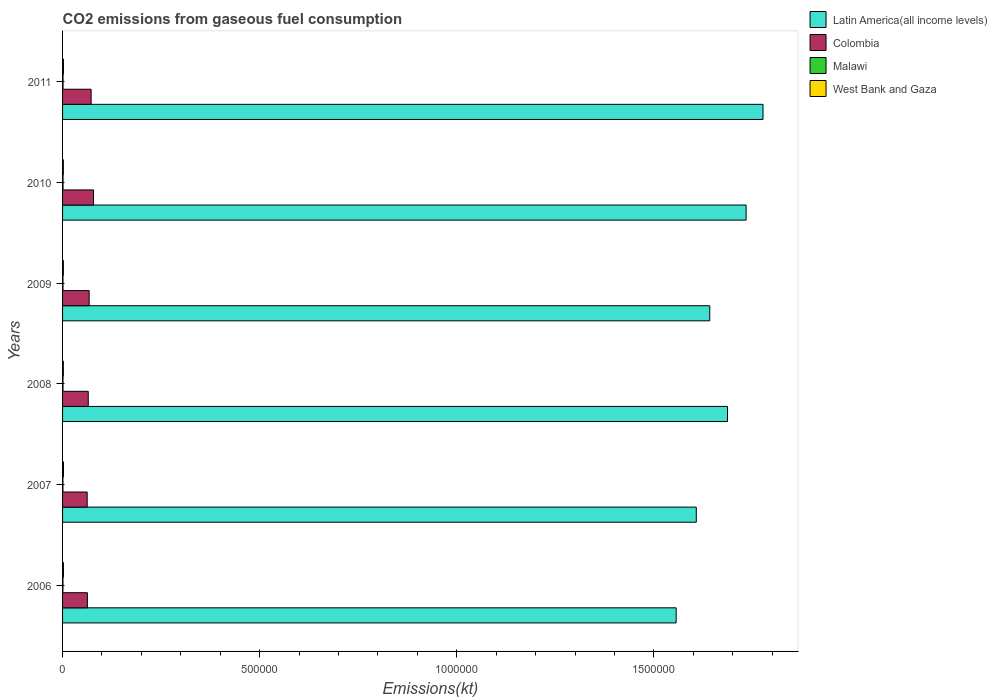Are the number of bars on each tick of the Y-axis equal?
Offer a terse response. Yes. How many bars are there on the 6th tick from the top?
Your response must be concise. 4. In how many cases, is the number of bars for a given year not equal to the number of legend labels?
Ensure brevity in your answer.  0. What is the amount of CO2 emitted in Malawi in 2011?
Provide a short and direct response. 1206.44. Across all years, what is the maximum amount of CO2 emitted in West Bank and Gaza?
Give a very brief answer. 2324.88. Across all years, what is the minimum amount of CO2 emitted in Malawi?
Ensure brevity in your answer.  953.42. What is the total amount of CO2 emitted in West Bank and Gaza in the graph?
Offer a very short reply. 1.30e+04. What is the difference between the amount of CO2 emitted in West Bank and Gaza in 2006 and that in 2007?
Your answer should be compact. -58.67. What is the difference between the amount of CO2 emitted in Malawi in 2009 and the amount of CO2 emitted in Latin America(all income levels) in 2008?
Offer a very short reply. -1.69e+06. What is the average amount of CO2 emitted in Colombia per year?
Your response must be concise. 6.82e+04. In the year 2008, what is the difference between the amount of CO2 emitted in Colombia and amount of CO2 emitted in Malawi?
Your answer should be very brief. 6.40e+04. In how many years, is the amount of CO2 emitted in Latin America(all income levels) greater than 700000 kt?
Ensure brevity in your answer.  6. What is the ratio of the amount of CO2 emitted in Colombia in 2008 to that in 2010?
Make the answer very short. 0.83. Is the amount of CO2 emitted in West Bank and Gaza in 2007 less than that in 2009?
Offer a terse response. No. Is the difference between the amount of CO2 emitted in Colombia in 2006 and 2009 greater than the difference between the amount of CO2 emitted in Malawi in 2006 and 2009?
Your answer should be very brief. No. What is the difference between the highest and the second highest amount of CO2 emitted in Malawi?
Your response must be concise. 7.33. What is the difference between the highest and the lowest amount of CO2 emitted in West Bank and Gaza?
Offer a terse response. 289.69. Is the sum of the amount of CO2 emitted in Malawi in 2007 and 2011 greater than the maximum amount of CO2 emitted in Latin America(all income levels) across all years?
Provide a succinct answer. No. Is it the case that in every year, the sum of the amount of CO2 emitted in Malawi and amount of CO2 emitted in Colombia is greater than the sum of amount of CO2 emitted in Latin America(all income levels) and amount of CO2 emitted in West Bank and Gaza?
Keep it short and to the point. Yes. What does the 4th bar from the top in 2008 represents?
Offer a very short reply. Latin America(all income levels). What does the 1st bar from the bottom in 2010 represents?
Keep it short and to the point. Latin America(all income levels). Are all the bars in the graph horizontal?
Provide a succinct answer. Yes. Are the values on the major ticks of X-axis written in scientific E-notation?
Your answer should be very brief. No. Does the graph contain grids?
Give a very brief answer. No. What is the title of the graph?
Offer a very short reply. CO2 emissions from gaseous fuel consumption. Does "Somalia" appear as one of the legend labels in the graph?
Ensure brevity in your answer.  No. What is the label or title of the X-axis?
Provide a succinct answer. Emissions(kt). What is the Emissions(kt) of Latin America(all income levels) in 2006?
Your response must be concise. 1.56e+06. What is the Emissions(kt) of Colombia in 2006?
Keep it short and to the point. 6.29e+04. What is the Emissions(kt) of Malawi in 2006?
Make the answer very short. 953.42. What is the Emissions(kt) of West Bank and Gaza in 2006?
Keep it short and to the point. 2266.21. What is the Emissions(kt) in Latin America(all income levels) in 2007?
Provide a succinct answer. 1.61e+06. What is the Emissions(kt) of Colombia in 2007?
Provide a short and direct response. 6.24e+04. What is the Emissions(kt) of Malawi in 2007?
Offer a terse response. 953.42. What is the Emissions(kt) of West Bank and Gaza in 2007?
Offer a very short reply. 2324.88. What is the Emissions(kt) in Latin America(all income levels) in 2008?
Ensure brevity in your answer.  1.69e+06. What is the Emissions(kt) of Colombia in 2008?
Offer a terse response. 6.52e+04. What is the Emissions(kt) of Malawi in 2008?
Provide a succinct answer. 1147.77. What is the Emissions(kt) in West Bank and Gaza in 2008?
Offer a very short reply. 2053.52. What is the Emissions(kt) of Latin America(all income levels) in 2009?
Offer a very short reply. 1.64e+06. What is the Emissions(kt) of Colombia in 2009?
Give a very brief answer. 6.74e+04. What is the Emissions(kt) of Malawi in 2009?
Offer a terse response. 1056.1. What is the Emissions(kt) in West Bank and Gaza in 2009?
Offer a terse response. 2090.19. What is the Emissions(kt) of Latin America(all income levels) in 2010?
Offer a terse response. 1.73e+06. What is the Emissions(kt) of Colombia in 2010?
Offer a very short reply. 7.86e+04. What is the Emissions(kt) of Malawi in 2010?
Ensure brevity in your answer.  1213.78. What is the Emissions(kt) in West Bank and Gaza in 2010?
Provide a succinct answer. 2035.18. What is the Emissions(kt) of Latin America(all income levels) in 2011?
Provide a short and direct response. 1.78e+06. What is the Emissions(kt) in Colombia in 2011?
Provide a short and direct response. 7.24e+04. What is the Emissions(kt) of Malawi in 2011?
Provide a short and direct response. 1206.44. What is the Emissions(kt) of West Bank and Gaza in 2011?
Your answer should be compact. 2247.87. Across all years, what is the maximum Emissions(kt) in Latin America(all income levels)?
Make the answer very short. 1.78e+06. Across all years, what is the maximum Emissions(kt) of Colombia?
Your response must be concise. 7.86e+04. Across all years, what is the maximum Emissions(kt) of Malawi?
Keep it short and to the point. 1213.78. Across all years, what is the maximum Emissions(kt) in West Bank and Gaza?
Your answer should be compact. 2324.88. Across all years, what is the minimum Emissions(kt) of Latin America(all income levels)?
Your answer should be compact. 1.56e+06. Across all years, what is the minimum Emissions(kt) of Colombia?
Your answer should be compact. 6.24e+04. Across all years, what is the minimum Emissions(kt) of Malawi?
Make the answer very short. 953.42. Across all years, what is the minimum Emissions(kt) of West Bank and Gaza?
Keep it short and to the point. 2035.18. What is the total Emissions(kt) in Latin America(all income levels) in the graph?
Provide a succinct answer. 1.00e+07. What is the total Emissions(kt) in Colombia in the graph?
Your answer should be very brief. 4.09e+05. What is the total Emissions(kt) in Malawi in the graph?
Your response must be concise. 6530.93. What is the total Emissions(kt) in West Bank and Gaza in the graph?
Ensure brevity in your answer.  1.30e+04. What is the difference between the Emissions(kt) of Latin America(all income levels) in 2006 and that in 2007?
Your answer should be compact. -5.11e+04. What is the difference between the Emissions(kt) in Colombia in 2006 and that in 2007?
Ensure brevity in your answer.  509.71. What is the difference between the Emissions(kt) of West Bank and Gaza in 2006 and that in 2007?
Ensure brevity in your answer.  -58.67. What is the difference between the Emissions(kt) of Latin America(all income levels) in 2006 and that in 2008?
Your answer should be very brief. -1.30e+05. What is the difference between the Emissions(kt) in Colombia in 2006 and that in 2008?
Offer a very short reply. -2218.53. What is the difference between the Emissions(kt) in Malawi in 2006 and that in 2008?
Your answer should be very brief. -194.35. What is the difference between the Emissions(kt) of West Bank and Gaza in 2006 and that in 2008?
Your answer should be compact. 212.69. What is the difference between the Emissions(kt) in Latin America(all income levels) in 2006 and that in 2009?
Provide a succinct answer. -8.52e+04. What is the difference between the Emissions(kt) of Colombia in 2006 and that in 2009?
Keep it short and to the point. -4492.07. What is the difference between the Emissions(kt) in Malawi in 2006 and that in 2009?
Make the answer very short. -102.68. What is the difference between the Emissions(kt) of West Bank and Gaza in 2006 and that in 2009?
Provide a short and direct response. 176.02. What is the difference between the Emissions(kt) of Latin America(all income levels) in 2006 and that in 2010?
Keep it short and to the point. -1.77e+05. What is the difference between the Emissions(kt) of Colombia in 2006 and that in 2010?
Offer a very short reply. -1.56e+04. What is the difference between the Emissions(kt) of Malawi in 2006 and that in 2010?
Your answer should be very brief. -260.36. What is the difference between the Emissions(kt) of West Bank and Gaza in 2006 and that in 2010?
Keep it short and to the point. 231.02. What is the difference between the Emissions(kt) in Latin America(all income levels) in 2006 and that in 2011?
Give a very brief answer. -2.20e+05. What is the difference between the Emissions(kt) of Colombia in 2006 and that in 2011?
Keep it short and to the point. -9482.86. What is the difference between the Emissions(kt) in Malawi in 2006 and that in 2011?
Offer a very short reply. -253.02. What is the difference between the Emissions(kt) in West Bank and Gaza in 2006 and that in 2011?
Your answer should be very brief. 18.34. What is the difference between the Emissions(kt) in Latin America(all income levels) in 2007 and that in 2008?
Make the answer very short. -7.91e+04. What is the difference between the Emissions(kt) in Colombia in 2007 and that in 2008?
Provide a short and direct response. -2728.25. What is the difference between the Emissions(kt) in Malawi in 2007 and that in 2008?
Provide a short and direct response. -194.35. What is the difference between the Emissions(kt) of West Bank and Gaza in 2007 and that in 2008?
Keep it short and to the point. 271.36. What is the difference between the Emissions(kt) in Latin America(all income levels) in 2007 and that in 2009?
Your response must be concise. -3.41e+04. What is the difference between the Emissions(kt) in Colombia in 2007 and that in 2009?
Offer a terse response. -5001.79. What is the difference between the Emissions(kt) of Malawi in 2007 and that in 2009?
Ensure brevity in your answer.  -102.68. What is the difference between the Emissions(kt) in West Bank and Gaza in 2007 and that in 2009?
Your response must be concise. 234.69. What is the difference between the Emissions(kt) in Latin America(all income levels) in 2007 and that in 2010?
Your answer should be compact. -1.26e+05. What is the difference between the Emissions(kt) in Colombia in 2007 and that in 2010?
Make the answer very short. -1.62e+04. What is the difference between the Emissions(kt) of Malawi in 2007 and that in 2010?
Provide a succinct answer. -260.36. What is the difference between the Emissions(kt) of West Bank and Gaza in 2007 and that in 2010?
Offer a very short reply. 289.69. What is the difference between the Emissions(kt) in Latin America(all income levels) in 2007 and that in 2011?
Your answer should be very brief. -1.69e+05. What is the difference between the Emissions(kt) in Colombia in 2007 and that in 2011?
Your answer should be very brief. -9992.58. What is the difference between the Emissions(kt) in Malawi in 2007 and that in 2011?
Ensure brevity in your answer.  -253.02. What is the difference between the Emissions(kt) in West Bank and Gaza in 2007 and that in 2011?
Provide a short and direct response. 77.01. What is the difference between the Emissions(kt) of Latin America(all income levels) in 2008 and that in 2009?
Keep it short and to the point. 4.50e+04. What is the difference between the Emissions(kt) in Colombia in 2008 and that in 2009?
Offer a very short reply. -2273.54. What is the difference between the Emissions(kt) in Malawi in 2008 and that in 2009?
Offer a very short reply. 91.67. What is the difference between the Emissions(kt) in West Bank and Gaza in 2008 and that in 2009?
Your answer should be very brief. -36.67. What is the difference between the Emissions(kt) of Latin America(all income levels) in 2008 and that in 2010?
Offer a terse response. -4.72e+04. What is the difference between the Emissions(kt) in Colombia in 2008 and that in 2010?
Provide a succinct answer. -1.34e+04. What is the difference between the Emissions(kt) of Malawi in 2008 and that in 2010?
Provide a short and direct response. -66.01. What is the difference between the Emissions(kt) in West Bank and Gaza in 2008 and that in 2010?
Your answer should be compact. 18.34. What is the difference between the Emissions(kt) in Latin America(all income levels) in 2008 and that in 2011?
Offer a terse response. -9.01e+04. What is the difference between the Emissions(kt) of Colombia in 2008 and that in 2011?
Provide a short and direct response. -7264.33. What is the difference between the Emissions(kt) in Malawi in 2008 and that in 2011?
Ensure brevity in your answer.  -58.67. What is the difference between the Emissions(kt) in West Bank and Gaza in 2008 and that in 2011?
Give a very brief answer. -194.35. What is the difference between the Emissions(kt) in Latin America(all income levels) in 2009 and that in 2010?
Keep it short and to the point. -9.22e+04. What is the difference between the Emissions(kt) of Colombia in 2009 and that in 2010?
Give a very brief answer. -1.12e+04. What is the difference between the Emissions(kt) in Malawi in 2009 and that in 2010?
Ensure brevity in your answer.  -157.68. What is the difference between the Emissions(kt) in West Bank and Gaza in 2009 and that in 2010?
Provide a succinct answer. 55.01. What is the difference between the Emissions(kt) in Latin America(all income levels) in 2009 and that in 2011?
Give a very brief answer. -1.35e+05. What is the difference between the Emissions(kt) of Colombia in 2009 and that in 2011?
Make the answer very short. -4990.79. What is the difference between the Emissions(kt) in Malawi in 2009 and that in 2011?
Your answer should be compact. -150.35. What is the difference between the Emissions(kt) of West Bank and Gaza in 2009 and that in 2011?
Give a very brief answer. -157.68. What is the difference between the Emissions(kt) of Latin America(all income levels) in 2010 and that in 2011?
Offer a terse response. -4.29e+04. What is the difference between the Emissions(kt) in Colombia in 2010 and that in 2011?
Keep it short and to the point. 6160.56. What is the difference between the Emissions(kt) of Malawi in 2010 and that in 2011?
Your response must be concise. 7.33. What is the difference between the Emissions(kt) in West Bank and Gaza in 2010 and that in 2011?
Your answer should be very brief. -212.69. What is the difference between the Emissions(kt) of Latin America(all income levels) in 2006 and the Emissions(kt) of Colombia in 2007?
Ensure brevity in your answer.  1.49e+06. What is the difference between the Emissions(kt) in Latin America(all income levels) in 2006 and the Emissions(kt) in Malawi in 2007?
Your response must be concise. 1.56e+06. What is the difference between the Emissions(kt) of Latin America(all income levels) in 2006 and the Emissions(kt) of West Bank and Gaza in 2007?
Make the answer very short. 1.55e+06. What is the difference between the Emissions(kt) in Colombia in 2006 and the Emissions(kt) in Malawi in 2007?
Keep it short and to the point. 6.20e+04. What is the difference between the Emissions(kt) in Colombia in 2006 and the Emissions(kt) in West Bank and Gaza in 2007?
Provide a succinct answer. 6.06e+04. What is the difference between the Emissions(kt) in Malawi in 2006 and the Emissions(kt) in West Bank and Gaza in 2007?
Offer a terse response. -1371.46. What is the difference between the Emissions(kt) in Latin America(all income levels) in 2006 and the Emissions(kt) in Colombia in 2008?
Offer a very short reply. 1.49e+06. What is the difference between the Emissions(kt) in Latin America(all income levels) in 2006 and the Emissions(kt) in Malawi in 2008?
Your response must be concise. 1.56e+06. What is the difference between the Emissions(kt) in Latin America(all income levels) in 2006 and the Emissions(kt) in West Bank and Gaza in 2008?
Your answer should be compact. 1.55e+06. What is the difference between the Emissions(kt) in Colombia in 2006 and the Emissions(kt) in Malawi in 2008?
Provide a succinct answer. 6.18e+04. What is the difference between the Emissions(kt) of Colombia in 2006 and the Emissions(kt) of West Bank and Gaza in 2008?
Provide a succinct answer. 6.09e+04. What is the difference between the Emissions(kt) of Malawi in 2006 and the Emissions(kt) of West Bank and Gaza in 2008?
Provide a short and direct response. -1100.1. What is the difference between the Emissions(kt) of Latin America(all income levels) in 2006 and the Emissions(kt) of Colombia in 2009?
Make the answer very short. 1.49e+06. What is the difference between the Emissions(kt) in Latin America(all income levels) in 2006 and the Emissions(kt) in Malawi in 2009?
Your answer should be very brief. 1.56e+06. What is the difference between the Emissions(kt) in Latin America(all income levels) in 2006 and the Emissions(kt) in West Bank and Gaza in 2009?
Give a very brief answer. 1.55e+06. What is the difference between the Emissions(kt) in Colombia in 2006 and the Emissions(kt) in Malawi in 2009?
Your answer should be compact. 6.19e+04. What is the difference between the Emissions(kt) in Colombia in 2006 and the Emissions(kt) in West Bank and Gaza in 2009?
Provide a short and direct response. 6.09e+04. What is the difference between the Emissions(kt) of Malawi in 2006 and the Emissions(kt) of West Bank and Gaza in 2009?
Provide a succinct answer. -1136.77. What is the difference between the Emissions(kt) of Latin America(all income levels) in 2006 and the Emissions(kt) of Colombia in 2010?
Ensure brevity in your answer.  1.48e+06. What is the difference between the Emissions(kt) in Latin America(all income levels) in 2006 and the Emissions(kt) in Malawi in 2010?
Keep it short and to the point. 1.56e+06. What is the difference between the Emissions(kt) in Latin America(all income levels) in 2006 and the Emissions(kt) in West Bank and Gaza in 2010?
Keep it short and to the point. 1.55e+06. What is the difference between the Emissions(kt) in Colombia in 2006 and the Emissions(kt) in Malawi in 2010?
Your answer should be very brief. 6.17e+04. What is the difference between the Emissions(kt) in Colombia in 2006 and the Emissions(kt) in West Bank and Gaza in 2010?
Provide a short and direct response. 6.09e+04. What is the difference between the Emissions(kt) of Malawi in 2006 and the Emissions(kt) of West Bank and Gaza in 2010?
Your answer should be compact. -1081.77. What is the difference between the Emissions(kt) in Latin America(all income levels) in 2006 and the Emissions(kt) in Colombia in 2011?
Make the answer very short. 1.48e+06. What is the difference between the Emissions(kt) in Latin America(all income levels) in 2006 and the Emissions(kt) in Malawi in 2011?
Your answer should be very brief. 1.56e+06. What is the difference between the Emissions(kt) in Latin America(all income levels) in 2006 and the Emissions(kt) in West Bank and Gaza in 2011?
Give a very brief answer. 1.55e+06. What is the difference between the Emissions(kt) in Colombia in 2006 and the Emissions(kt) in Malawi in 2011?
Make the answer very short. 6.17e+04. What is the difference between the Emissions(kt) of Colombia in 2006 and the Emissions(kt) of West Bank and Gaza in 2011?
Offer a very short reply. 6.07e+04. What is the difference between the Emissions(kt) in Malawi in 2006 and the Emissions(kt) in West Bank and Gaza in 2011?
Provide a succinct answer. -1294.45. What is the difference between the Emissions(kt) of Latin America(all income levels) in 2007 and the Emissions(kt) of Colombia in 2008?
Your response must be concise. 1.54e+06. What is the difference between the Emissions(kt) in Latin America(all income levels) in 2007 and the Emissions(kt) in Malawi in 2008?
Offer a very short reply. 1.61e+06. What is the difference between the Emissions(kt) of Latin America(all income levels) in 2007 and the Emissions(kt) of West Bank and Gaza in 2008?
Make the answer very short. 1.61e+06. What is the difference between the Emissions(kt) in Colombia in 2007 and the Emissions(kt) in Malawi in 2008?
Provide a short and direct response. 6.13e+04. What is the difference between the Emissions(kt) of Colombia in 2007 and the Emissions(kt) of West Bank and Gaza in 2008?
Your answer should be very brief. 6.04e+04. What is the difference between the Emissions(kt) in Malawi in 2007 and the Emissions(kt) in West Bank and Gaza in 2008?
Provide a succinct answer. -1100.1. What is the difference between the Emissions(kt) of Latin America(all income levels) in 2007 and the Emissions(kt) of Colombia in 2009?
Provide a short and direct response. 1.54e+06. What is the difference between the Emissions(kt) in Latin America(all income levels) in 2007 and the Emissions(kt) in Malawi in 2009?
Provide a succinct answer. 1.61e+06. What is the difference between the Emissions(kt) in Latin America(all income levels) in 2007 and the Emissions(kt) in West Bank and Gaza in 2009?
Your answer should be very brief. 1.61e+06. What is the difference between the Emissions(kt) in Colombia in 2007 and the Emissions(kt) in Malawi in 2009?
Make the answer very short. 6.14e+04. What is the difference between the Emissions(kt) of Colombia in 2007 and the Emissions(kt) of West Bank and Gaza in 2009?
Give a very brief answer. 6.03e+04. What is the difference between the Emissions(kt) of Malawi in 2007 and the Emissions(kt) of West Bank and Gaza in 2009?
Offer a terse response. -1136.77. What is the difference between the Emissions(kt) in Latin America(all income levels) in 2007 and the Emissions(kt) in Colombia in 2010?
Your answer should be compact. 1.53e+06. What is the difference between the Emissions(kt) in Latin America(all income levels) in 2007 and the Emissions(kt) in Malawi in 2010?
Keep it short and to the point. 1.61e+06. What is the difference between the Emissions(kt) in Latin America(all income levels) in 2007 and the Emissions(kt) in West Bank and Gaza in 2010?
Offer a very short reply. 1.61e+06. What is the difference between the Emissions(kt) of Colombia in 2007 and the Emissions(kt) of Malawi in 2010?
Ensure brevity in your answer.  6.12e+04. What is the difference between the Emissions(kt) in Colombia in 2007 and the Emissions(kt) in West Bank and Gaza in 2010?
Make the answer very short. 6.04e+04. What is the difference between the Emissions(kt) of Malawi in 2007 and the Emissions(kt) of West Bank and Gaza in 2010?
Ensure brevity in your answer.  -1081.77. What is the difference between the Emissions(kt) in Latin America(all income levels) in 2007 and the Emissions(kt) in Colombia in 2011?
Give a very brief answer. 1.53e+06. What is the difference between the Emissions(kt) of Latin America(all income levels) in 2007 and the Emissions(kt) of Malawi in 2011?
Provide a succinct answer. 1.61e+06. What is the difference between the Emissions(kt) in Latin America(all income levels) in 2007 and the Emissions(kt) in West Bank and Gaza in 2011?
Offer a terse response. 1.61e+06. What is the difference between the Emissions(kt) in Colombia in 2007 and the Emissions(kt) in Malawi in 2011?
Your answer should be very brief. 6.12e+04. What is the difference between the Emissions(kt) in Colombia in 2007 and the Emissions(kt) in West Bank and Gaza in 2011?
Offer a terse response. 6.02e+04. What is the difference between the Emissions(kt) in Malawi in 2007 and the Emissions(kt) in West Bank and Gaza in 2011?
Your answer should be compact. -1294.45. What is the difference between the Emissions(kt) in Latin America(all income levels) in 2008 and the Emissions(kt) in Colombia in 2009?
Your answer should be compact. 1.62e+06. What is the difference between the Emissions(kt) of Latin America(all income levels) in 2008 and the Emissions(kt) of Malawi in 2009?
Keep it short and to the point. 1.69e+06. What is the difference between the Emissions(kt) of Latin America(all income levels) in 2008 and the Emissions(kt) of West Bank and Gaza in 2009?
Offer a terse response. 1.68e+06. What is the difference between the Emissions(kt) of Colombia in 2008 and the Emissions(kt) of Malawi in 2009?
Provide a short and direct response. 6.41e+04. What is the difference between the Emissions(kt) in Colombia in 2008 and the Emissions(kt) in West Bank and Gaza in 2009?
Give a very brief answer. 6.31e+04. What is the difference between the Emissions(kt) of Malawi in 2008 and the Emissions(kt) of West Bank and Gaza in 2009?
Your response must be concise. -942.42. What is the difference between the Emissions(kt) in Latin America(all income levels) in 2008 and the Emissions(kt) in Colombia in 2010?
Offer a terse response. 1.61e+06. What is the difference between the Emissions(kt) in Latin America(all income levels) in 2008 and the Emissions(kt) in Malawi in 2010?
Make the answer very short. 1.69e+06. What is the difference between the Emissions(kt) in Latin America(all income levels) in 2008 and the Emissions(kt) in West Bank and Gaza in 2010?
Your answer should be compact. 1.68e+06. What is the difference between the Emissions(kt) in Colombia in 2008 and the Emissions(kt) in Malawi in 2010?
Your answer should be compact. 6.39e+04. What is the difference between the Emissions(kt) in Colombia in 2008 and the Emissions(kt) in West Bank and Gaza in 2010?
Your response must be concise. 6.31e+04. What is the difference between the Emissions(kt) of Malawi in 2008 and the Emissions(kt) of West Bank and Gaza in 2010?
Offer a terse response. -887.41. What is the difference between the Emissions(kt) of Latin America(all income levels) in 2008 and the Emissions(kt) of Colombia in 2011?
Your answer should be very brief. 1.61e+06. What is the difference between the Emissions(kt) of Latin America(all income levels) in 2008 and the Emissions(kt) of Malawi in 2011?
Your answer should be compact. 1.69e+06. What is the difference between the Emissions(kt) of Latin America(all income levels) in 2008 and the Emissions(kt) of West Bank and Gaza in 2011?
Offer a very short reply. 1.68e+06. What is the difference between the Emissions(kt) in Colombia in 2008 and the Emissions(kt) in Malawi in 2011?
Provide a short and direct response. 6.40e+04. What is the difference between the Emissions(kt) of Colombia in 2008 and the Emissions(kt) of West Bank and Gaza in 2011?
Provide a short and direct response. 6.29e+04. What is the difference between the Emissions(kt) of Malawi in 2008 and the Emissions(kt) of West Bank and Gaza in 2011?
Offer a very short reply. -1100.1. What is the difference between the Emissions(kt) in Latin America(all income levels) in 2009 and the Emissions(kt) in Colombia in 2010?
Provide a short and direct response. 1.56e+06. What is the difference between the Emissions(kt) of Latin America(all income levels) in 2009 and the Emissions(kt) of Malawi in 2010?
Give a very brief answer. 1.64e+06. What is the difference between the Emissions(kt) of Latin America(all income levels) in 2009 and the Emissions(kt) of West Bank and Gaza in 2010?
Provide a succinct answer. 1.64e+06. What is the difference between the Emissions(kt) in Colombia in 2009 and the Emissions(kt) in Malawi in 2010?
Your answer should be compact. 6.62e+04. What is the difference between the Emissions(kt) in Colombia in 2009 and the Emissions(kt) in West Bank and Gaza in 2010?
Your response must be concise. 6.54e+04. What is the difference between the Emissions(kt) of Malawi in 2009 and the Emissions(kt) of West Bank and Gaza in 2010?
Ensure brevity in your answer.  -979.09. What is the difference between the Emissions(kt) in Latin America(all income levels) in 2009 and the Emissions(kt) in Colombia in 2011?
Provide a short and direct response. 1.57e+06. What is the difference between the Emissions(kt) in Latin America(all income levels) in 2009 and the Emissions(kt) in Malawi in 2011?
Ensure brevity in your answer.  1.64e+06. What is the difference between the Emissions(kt) of Latin America(all income levels) in 2009 and the Emissions(kt) of West Bank and Gaza in 2011?
Give a very brief answer. 1.64e+06. What is the difference between the Emissions(kt) in Colombia in 2009 and the Emissions(kt) in Malawi in 2011?
Give a very brief answer. 6.62e+04. What is the difference between the Emissions(kt) of Colombia in 2009 and the Emissions(kt) of West Bank and Gaza in 2011?
Give a very brief answer. 6.52e+04. What is the difference between the Emissions(kt) in Malawi in 2009 and the Emissions(kt) in West Bank and Gaza in 2011?
Offer a very short reply. -1191.78. What is the difference between the Emissions(kt) in Latin America(all income levels) in 2010 and the Emissions(kt) in Colombia in 2011?
Ensure brevity in your answer.  1.66e+06. What is the difference between the Emissions(kt) in Latin America(all income levels) in 2010 and the Emissions(kt) in Malawi in 2011?
Give a very brief answer. 1.73e+06. What is the difference between the Emissions(kt) in Latin America(all income levels) in 2010 and the Emissions(kt) in West Bank and Gaza in 2011?
Your answer should be very brief. 1.73e+06. What is the difference between the Emissions(kt) of Colombia in 2010 and the Emissions(kt) of Malawi in 2011?
Offer a very short reply. 7.74e+04. What is the difference between the Emissions(kt) in Colombia in 2010 and the Emissions(kt) in West Bank and Gaza in 2011?
Your response must be concise. 7.63e+04. What is the difference between the Emissions(kt) in Malawi in 2010 and the Emissions(kt) in West Bank and Gaza in 2011?
Give a very brief answer. -1034.09. What is the average Emissions(kt) of Latin America(all income levels) per year?
Your response must be concise. 1.67e+06. What is the average Emissions(kt) in Colombia per year?
Ensure brevity in your answer.  6.82e+04. What is the average Emissions(kt) of Malawi per year?
Provide a short and direct response. 1088.49. What is the average Emissions(kt) in West Bank and Gaza per year?
Your answer should be compact. 2169.64. In the year 2006, what is the difference between the Emissions(kt) in Latin America(all income levels) and Emissions(kt) in Colombia?
Give a very brief answer. 1.49e+06. In the year 2006, what is the difference between the Emissions(kt) in Latin America(all income levels) and Emissions(kt) in Malawi?
Provide a short and direct response. 1.56e+06. In the year 2006, what is the difference between the Emissions(kt) in Latin America(all income levels) and Emissions(kt) in West Bank and Gaza?
Make the answer very short. 1.55e+06. In the year 2006, what is the difference between the Emissions(kt) of Colombia and Emissions(kt) of Malawi?
Offer a terse response. 6.20e+04. In the year 2006, what is the difference between the Emissions(kt) of Colombia and Emissions(kt) of West Bank and Gaza?
Your answer should be very brief. 6.07e+04. In the year 2006, what is the difference between the Emissions(kt) in Malawi and Emissions(kt) in West Bank and Gaza?
Provide a succinct answer. -1312.79. In the year 2007, what is the difference between the Emissions(kt) of Latin America(all income levels) and Emissions(kt) of Colombia?
Your answer should be very brief. 1.54e+06. In the year 2007, what is the difference between the Emissions(kt) in Latin America(all income levels) and Emissions(kt) in Malawi?
Offer a very short reply. 1.61e+06. In the year 2007, what is the difference between the Emissions(kt) of Latin America(all income levels) and Emissions(kt) of West Bank and Gaza?
Offer a terse response. 1.61e+06. In the year 2007, what is the difference between the Emissions(kt) of Colombia and Emissions(kt) of Malawi?
Ensure brevity in your answer.  6.15e+04. In the year 2007, what is the difference between the Emissions(kt) of Colombia and Emissions(kt) of West Bank and Gaza?
Ensure brevity in your answer.  6.01e+04. In the year 2007, what is the difference between the Emissions(kt) in Malawi and Emissions(kt) in West Bank and Gaza?
Ensure brevity in your answer.  -1371.46. In the year 2008, what is the difference between the Emissions(kt) of Latin America(all income levels) and Emissions(kt) of Colombia?
Your answer should be very brief. 1.62e+06. In the year 2008, what is the difference between the Emissions(kt) of Latin America(all income levels) and Emissions(kt) of Malawi?
Your answer should be compact. 1.69e+06. In the year 2008, what is the difference between the Emissions(kt) of Latin America(all income levels) and Emissions(kt) of West Bank and Gaza?
Your answer should be compact. 1.68e+06. In the year 2008, what is the difference between the Emissions(kt) of Colombia and Emissions(kt) of Malawi?
Make the answer very short. 6.40e+04. In the year 2008, what is the difference between the Emissions(kt) in Colombia and Emissions(kt) in West Bank and Gaza?
Ensure brevity in your answer.  6.31e+04. In the year 2008, what is the difference between the Emissions(kt) in Malawi and Emissions(kt) in West Bank and Gaza?
Give a very brief answer. -905.75. In the year 2009, what is the difference between the Emissions(kt) in Latin America(all income levels) and Emissions(kt) in Colombia?
Give a very brief answer. 1.57e+06. In the year 2009, what is the difference between the Emissions(kt) of Latin America(all income levels) and Emissions(kt) of Malawi?
Ensure brevity in your answer.  1.64e+06. In the year 2009, what is the difference between the Emissions(kt) of Latin America(all income levels) and Emissions(kt) of West Bank and Gaza?
Make the answer very short. 1.64e+06. In the year 2009, what is the difference between the Emissions(kt) of Colombia and Emissions(kt) of Malawi?
Your answer should be very brief. 6.64e+04. In the year 2009, what is the difference between the Emissions(kt) in Colombia and Emissions(kt) in West Bank and Gaza?
Your answer should be very brief. 6.53e+04. In the year 2009, what is the difference between the Emissions(kt) in Malawi and Emissions(kt) in West Bank and Gaza?
Keep it short and to the point. -1034.09. In the year 2010, what is the difference between the Emissions(kt) of Latin America(all income levels) and Emissions(kt) of Colombia?
Make the answer very short. 1.66e+06. In the year 2010, what is the difference between the Emissions(kt) of Latin America(all income levels) and Emissions(kt) of Malawi?
Offer a very short reply. 1.73e+06. In the year 2010, what is the difference between the Emissions(kt) in Latin America(all income levels) and Emissions(kt) in West Bank and Gaza?
Provide a succinct answer. 1.73e+06. In the year 2010, what is the difference between the Emissions(kt) in Colombia and Emissions(kt) in Malawi?
Make the answer very short. 7.74e+04. In the year 2010, what is the difference between the Emissions(kt) of Colombia and Emissions(kt) of West Bank and Gaza?
Keep it short and to the point. 7.65e+04. In the year 2010, what is the difference between the Emissions(kt) in Malawi and Emissions(kt) in West Bank and Gaza?
Make the answer very short. -821.41. In the year 2011, what is the difference between the Emissions(kt) of Latin America(all income levels) and Emissions(kt) of Colombia?
Offer a very short reply. 1.70e+06. In the year 2011, what is the difference between the Emissions(kt) of Latin America(all income levels) and Emissions(kt) of Malawi?
Give a very brief answer. 1.78e+06. In the year 2011, what is the difference between the Emissions(kt) of Latin America(all income levels) and Emissions(kt) of West Bank and Gaza?
Ensure brevity in your answer.  1.77e+06. In the year 2011, what is the difference between the Emissions(kt) in Colombia and Emissions(kt) in Malawi?
Give a very brief answer. 7.12e+04. In the year 2011, what is the difference between the Emissions(kt) in Colombia and Emissions(kt) in West Bank and Gaza?
Offer a very short reply. 7.02e+04. In the year 2011, what is the difference between the Emissions(kt) in Malawi and Emissions(kt) in West Bank and Gaza?
Offer a terse response. -1041.43. What is the ratio of the Emissions(kt) in Latin America(all income levels) in 2006 to that in 2007?
Offer a terse response. 0.97. What is the ratio of the Emissions(kt) in Colombia in 2006 to that in 2007?
Give a very brief answer. 1.01. What is the ratio of the Emissions(kt) in West Bank and Gaza in 2006 to that in 2007?
Offer a very short reply. 0.97. What is the ratio of the Emissions(kt) in Latin America(all income levels) in 2006 to that in 2008?
Make the answer very short. 0.92. What is the ratio of the Emissions(kt) of Colombia in 2006 to that in 2008?
Your answer should be compact. 0.97. What is the ratio of the Emissions(kt) of Malawi in 2006 to that in 2008?
Keep it short and to the point. 0.83. What is the ratio of the Emissions(kt) in West Bank and Gaza in 2006 to that in 2008?
Provide a succinct answer. 1.1. What is the ratio of the Emissions(kt) in Latin America(all income levels) in 2006 to that in 2009?
Give a very brief answer. 0.95. What is the ratio of the Emissions(kt) in Colombia in 2006 to that in 2009?
Provide a succinct answer. 0.93. What is the ratio of the Emissions(kt) of Malawi in 2006 to that in 2009?
Your answer should be compact. 0.9. What is the ratio of the Emissions(kt) of West Bank and Gaza in 2006 to that in 2009?
Offer a terse response. 1.08. What is the ratio of the Emissions(kt) in Latin America(all income levels) in 2006 to that in 2010?
Provide a short and direct response. 0.9. What is the ratio of the Emissions(kt) in Colombia in 2006 to that in 2010?
Make the answer very short. 0.8. What is the ratio of the Emissions(kt) in Malawi in 2006 to that in 2010?
Keep it short and to the point. 0.79. What is the ratio of the Emissions(kt) of West Bank and Gaza in 2006 to that in 2010?
Give a very brief answer. 1.11. What is the ratio of the Emissions(kt) of Latin America(all income levels) in 2006 to that in 2011?
Offer a terse response. 0.88. What is the ratio of the Emissions(kt) in Colombia in 2006 to that in 2011?
Provide a succinct answer. 0.87. What is the ratio of the Emissions(kt) in Malawi in 2006 to that in 2011?
Make the answer very short. 0.79. What is the ratio of the Emissions(kt) in West Bank and Gaza in 2006 to that in 2011?
Your response must be concise. 1.01. What is the ratio of the Emissions(kt) of Latin America(all income levels) in 2007 to that in 2008?
Make the answer very short. 0.95. What is the ratio of the Emissions(kt) of Colombia in 2007 to that in 2008?
Provide a succinct answer. 0.96. What is the ratio of the Emissions(kt) of Malawi in 2007 to that in 2008?
Keep it short and to the point. 0.83. What is the ratio of the Emissions(kt) of West Bank and Gaza in 2007 to that in 2008?
Make the answer very short. 1.13. What is the ratio of the Emissions(kt) of Latin America(all income levels) in 2007 to that in 2009?
Your answer should be compact. 0.98. What is the ratio of the Emissions(kt) of Colombia in 2007 to that in 2009?
Ensure brevity in your answer.  0.93. What is the ratio of the Emissions(kt) in Malawi in 2007 to that in 2009?
Provide a short and direct response. 0.9. What is the ratio of the Emissions(kt) in West Bank and Gaza in 2007 to that in 2009?
Offer a very short reply. 1.11. What is the ratio of the Emissions(kt) in Latin America(all income levels) in 2007 to that in 2010?
Offer a terse response. 0.93. What is the ratio of the Emissions(kt) of Colombia in 2007 to that in 2010?
Provide a short and direct response. 0.79. What is the ratio of the Emissions(kt) of Malawi in 2007 to that in 2010?
Ensure brevity in your answer.  0.79. What is the ratio of the Emissions(kt) of West Bank and Gaza in 2007 to that in 2010?
Provide a short and direct response. 1.14. What is the ratio of the Emissions(kt) of Latin America(all income levels) in 2007 to that in 2011?
Offer a very short reply. 0.9. What is the ratio of the Emissions(kt) of Colombia in 2007 to that in 2011?
Provide a short and direct response. 0.86. What is the ratio of the Emissions(kt) of Malawi in 2007 to that in 2011?
Your answer should be compact. 0.79. What is the ratio of the Emissions(kt) in West Bank and Gaza in 2007 to that in 2011?
Ensure brevity in your answer.  1.03. What is the ratio of the Emissions(kt) of Latin America(all income levels) in 2008 to that in 2009?
Make the answer very short. 1.03. What is the ratio of the Emissions(kt) in Colombia in 2008 to that in 2009?
Offer a terse response. 0.97. What is the ratio of the Emissions(kt) of Malawi in 2008 to that in 2009?
Give a very brief answer. 1.09. What is the ratio of the Emissions(kt) of West Bank and Gaza in 2008 to that in 2009?
Provide a succinct answer. 0.98. What is the ratio of the Emissions(kt) of Latin America(all income levels) in 2008 to that in 2010?
Your answer should be very brief. 0.97. What is the ratio of the Emissions(kt) of Colombia in 2008 to that in 2010?
Ensure brevity in your answer.  0.83. What is the ratio of the Emissions(kt) in Malawi in 2008 to that in 2010?
Provide a short and direct response. 0.95. What is the ratio of the Emissions(kt) of West Bank and Gaza in 2008 to that in 2010?
Keep it short and to the point. 1.01. What is the ratio of the Emissions(kt) in Latin America(all income levels) in 2008 to that in 2011?
Your answer should be compact. 0.95. What is the ratio of the Emissions(kt) of Colombia in 2008 to that in 2011?
Your answer should be very brief. 0.9. What is the ratio of the Emissions(kt) of Malawi in 2008 to that in 2011?
Your answer should be compact. 0.95. What is the ratio of the Emissions(kt) in West Bank and Gaza in 2008 to that in 2011?
Offer a very short reply. 0.91. What is the ratio of the Emissions(kt) of Latin America(all income levels) in 2009 to that in 2010?
Keep it short and to the point. 0.95. What is the ratio of the Emissions(kt) in Colombia in 2009 to that in 2010?
Your response must be concise. 0.86. What is the ratio of the Emissions(kt) of Malawi in 2009 to that in 2010?
Your answer should be very brief. 0.87. What is the ratio of the Emissions(kt) of West Bank and Gaza in 2009 to that in 2010?
Ensure brevity in your answer.  1.03. What is the ratio of the Emissions(kt) in Latin America(all income levels) in 2009 to that in 2011?
Keep it short and to the point. 0.92. What is the ratio of the Emissions(kt) of Colombia in 2009 to that in 2011?
Ensure brevity in your answer.  0.93. What is the ratio of the Emissions(kt) of Malawi in 2009 to that in 2011?
Offer a terse response. 0.88. What is the ratio of the Emissions(kt) of West Bank and Gaza in 2009 to that in 2011?
Offer a very short reply. 0.93. What is the ratio of the Emissions(kt) of Latin America(all income levels) in 2010 to that in 2011?
Your response must be concise. 0.98. What is the ratio of the Emissions(kt) in Colombia in 2010 to that in 2011?
Provide a succinct answer. 1.09. What is the ratio of the Emissions(kt) of West Bank and Gaza in 2010 to that in 2011?
Make the answer very short. 0.91. What is the difference between the highest and the second highest Emissions(kt) in Latin America(all income levels)?
Ensure brevity in your answer.  4.29e+04. What is the difference between the highest and the second highest Emissions(kt) in Colombia?
Your answer should be compact. 6160.56. What is the difference between the highest and the second highest Emissions(kt) of Malawi?
Give a very brief answer. 7.33. What is the difference between the highest and the second highest Emissions(kt) in West Bank and Gaza?
Provide a short and direct response. 58.67. What is the difference between the highest and the lowest Emissions(kt) of Latin America(all income levels)?
Ensure brevity in your answer.  2.20e+05. What is the difference between the highest and the lowest Emissions(kt) of Colombia?
Provide a succinct answer. 1.62e+04. What is the difference between the highest and the lowest Emissions(kt) in Malawi?
Offer a terse response. 260.36. What is the difference between the highest and the lowest Emissions(kt) in West Bank and Gaza?
Your response must be concise. 289.69. 